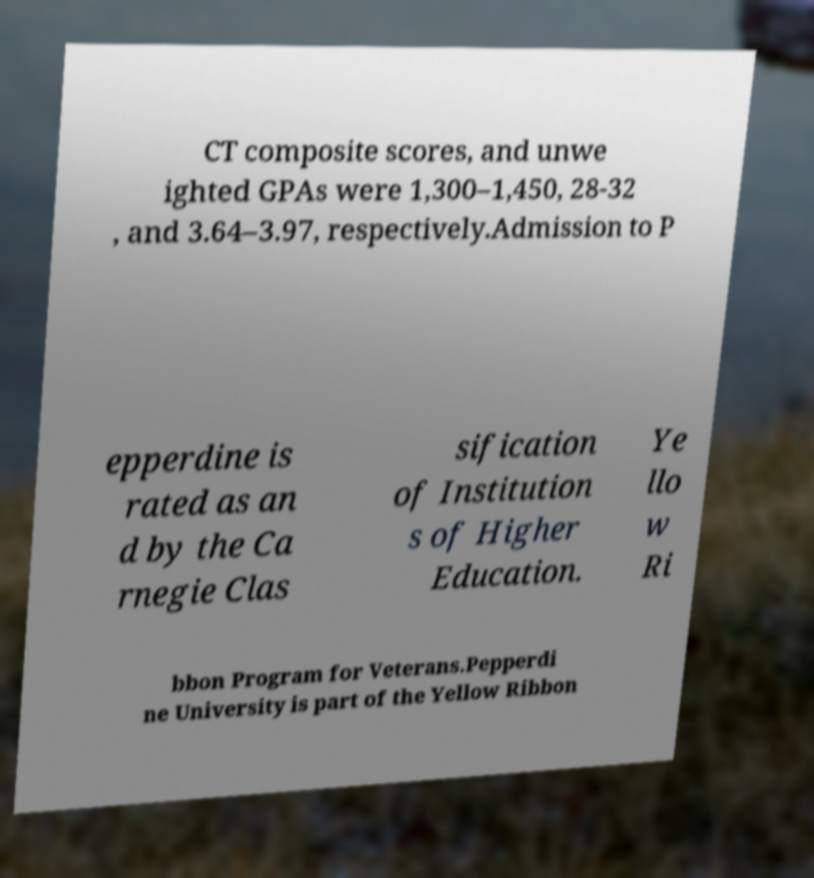Could you assist in decoding the text presented in this image and type it out clearly? CT composite scores, and unwe ighted GPAs were 1,300–1,450, 28-32 , and 3.64–3.97, respectively.Admission to P epperdine is rated as an d by the Ca rnegie Clas sification of Institution s of Higher Education. Ye llo w Ri bbon Program for Veterans.Pepperdi ne University is part of the Yellow Ribbon 